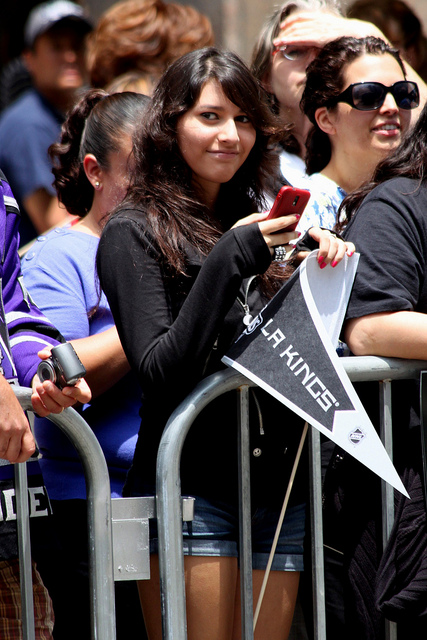Please transcribe the text information in this image. LA KINGS 